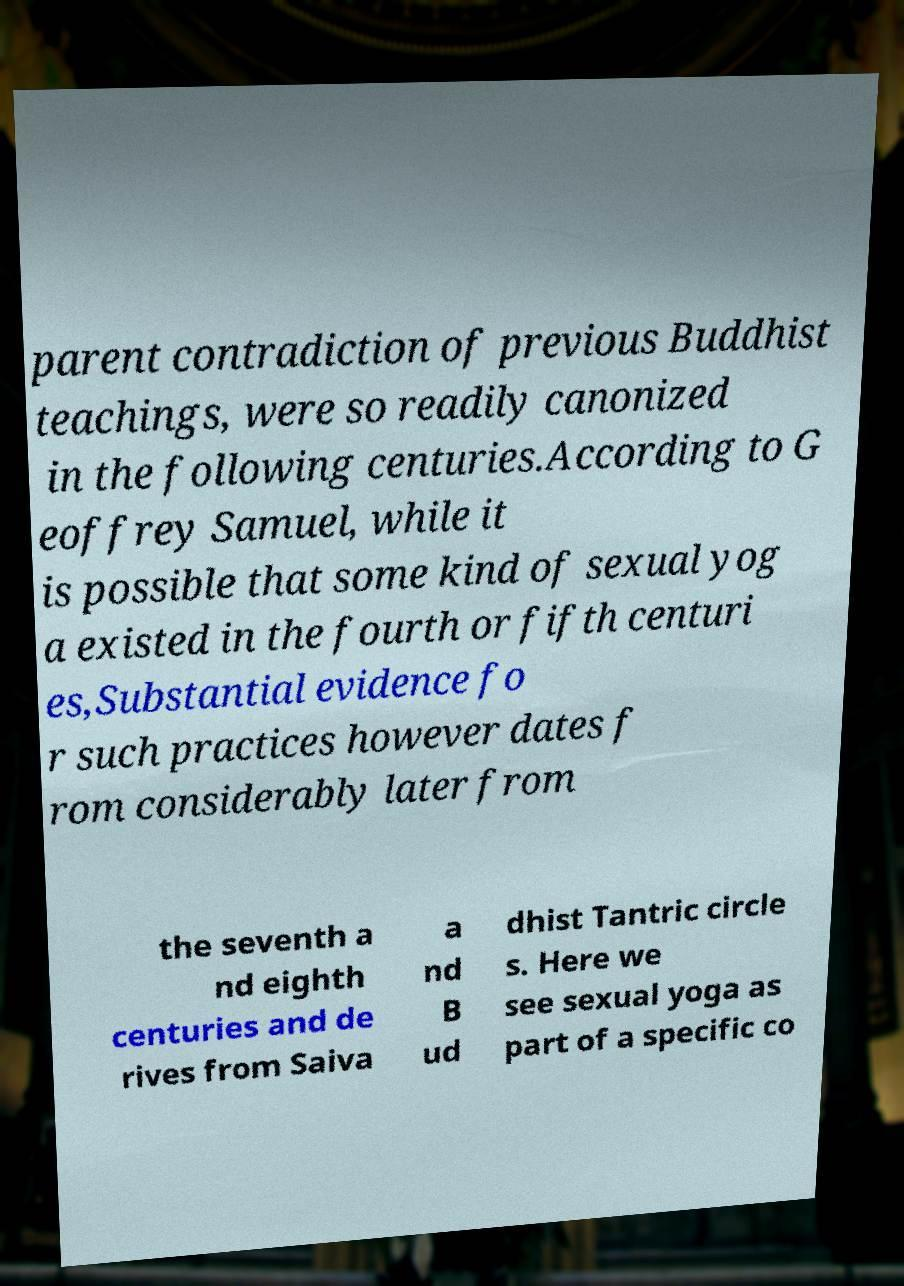There's text embedded in this image that I need extracted. Can you transcribe it verbatim? parent contradiction of previous Buddhist teachings, were so readily canonized in the following centuries.According to G eoffrey Samuel, while it is possible that some kind of sexual yog a existed in the fourth or fifth centuri es,Substantial evidence fo r such practices however dates f rom considerably later from the seventh a nd eighth centuries and de rives from Saiva a nd B ud dhist Tantric circle s. Here we see sexual yoga as part of a specific co 